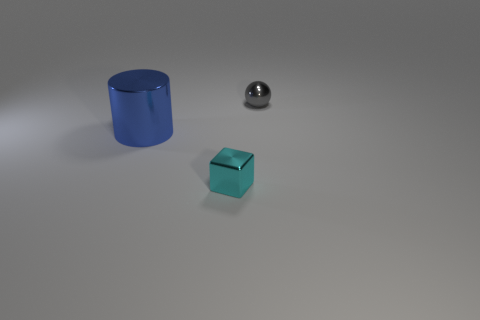Is the shape of the tiny thing that is behind the big blue metal object the same as  the large blue object?
Your answer should be very brief. No. What color is the metal object that is on the right side of the tiny cyan metal thing?
Your answer should be very brief. Gray. What shape is the gray object that is the same material as the big blue object?
Offer a very short reply. Sphere. Is there anything else that has the same color as the tiny sphere?
Your answer should be very brief. No. Are there more tiny shiny things left of the large blue shiny cylinder than small gray spheres left of the gray shiny sphere?
Make the answer very short. No. What number of other metallic spheres are the same size as the sphere?
Give a very brief answer. 0. Are there fewer shiny things that are behind the tiny cyan metal object than tiny gray balls that are on the left side of the blue cylinder?
Keep it short and to the point. No. Are there any other big metallic objects that have the same shape as the big metallic object?
Give a very brief answer. No. Is the shape of the big object the same as the gray metallic object?
Give a very brief answer. No. How many large objects are cyan cubes or brown metallic things?
Make the answer very short. 0. 